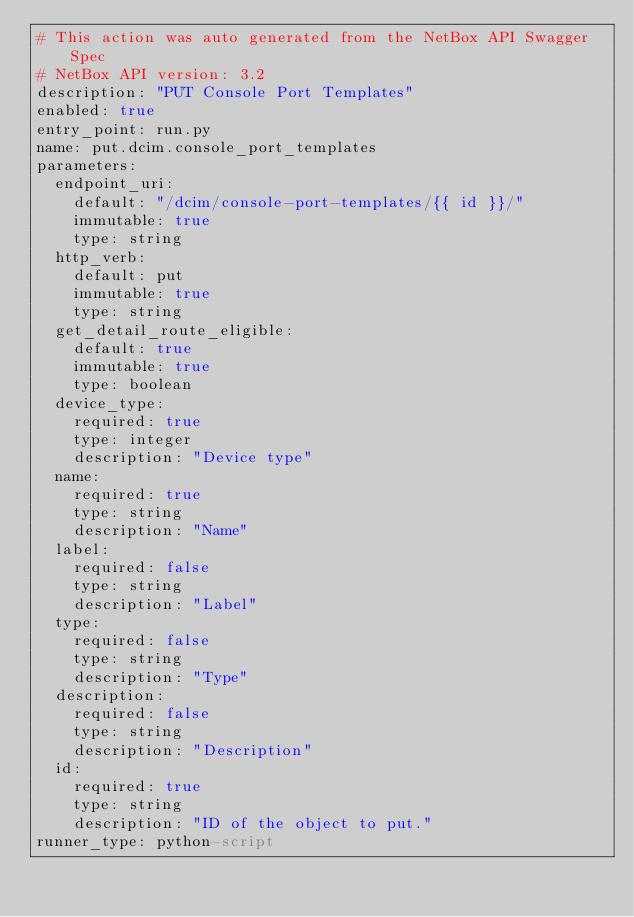<code> <loc_0><loc_0><loc_500><loc_500><_YAML_># This action was auto generated from the NetBox API Swagger Spec
# NetBox API version: 3.2
description: "PUT Console Port Templates"
enabled: true
entry_point: run.py
name: put.dcim.console_port_templates
parameters:
  endpoint_uri:
    default: "/dcim/console-port-templates/{{ id }}/"
    immutable: true
    type: string
  http_verb:
    default: put
    immutable: true
    type: string
  get_detail_route_eligible:
    default: true
    immutable: true
    type: boolean
  device_type:
    required: true
    type: integer
    description: "Device type"
  name:
    required: true
    type: string
    description: "Name"
  label:
    required: false
    type: string
    description: "Label"
  type:
    required: false
    type: string
    description: "Type"
  description:
    required: false
    type: string
    description: "Description"
  id:
    required: true
    type: string
    description: "ID of the object to put."
runner_type: python-script</code> 